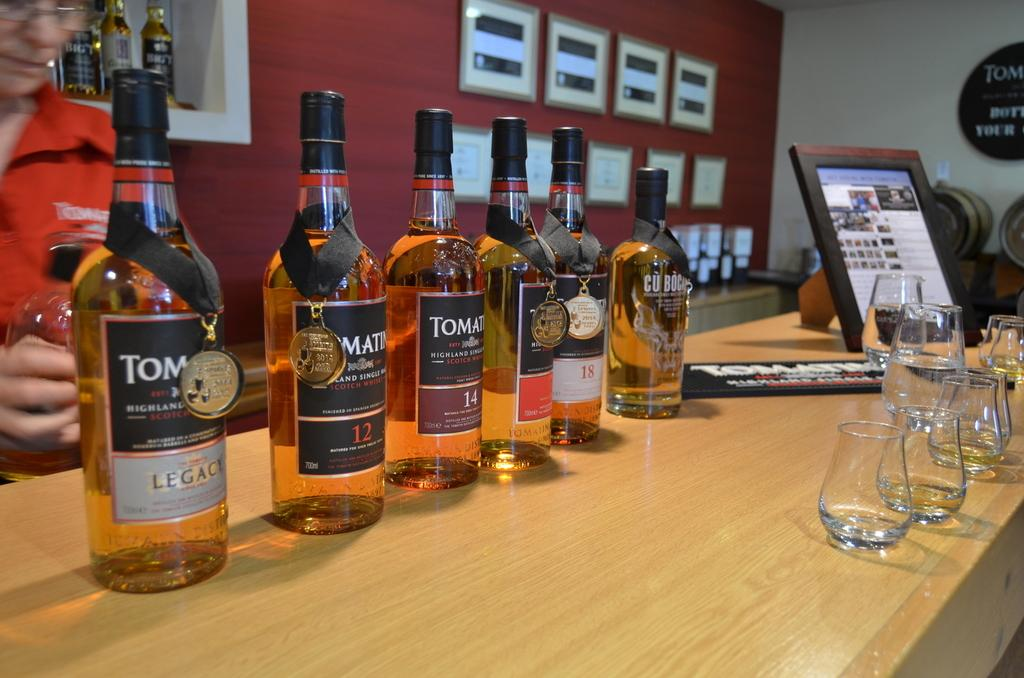<image>
Relay a brief, clear account of the picture shown. Lined up on a table are several bottles, including Legacy, 12, 14, and 18. 